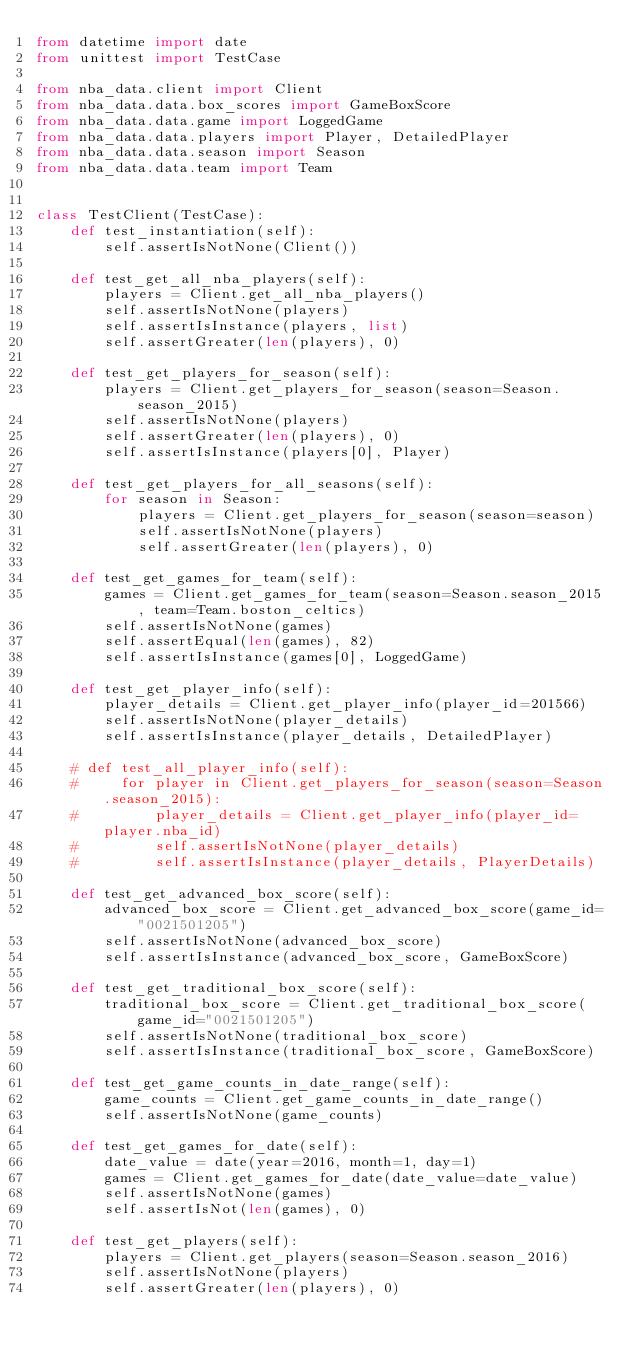<code> <loc_0><loc_0><loc_500><loc_500><_Python_>from datetime import date
from unittest import TestCase

from nba_data.client import Client
from nba_data.data.box_scores import GameBoxScore
from nba_data.data.game import LoggedGame
from nba_data.data.players import Player, DetailedPlayer
from nba_data.data.season import Season
from nba_data.data.team import Team


class TestClient(TestCase):
    def test_instantiation(self):
        self.assertIsNotNone(Client())

    def test_get_all_nba_players(self):
        players = Client.get_all_nba_players()
        self.assertIsNotNone(players)
        self.assertIsInstance(players, list)
        self.assertGreater(len(players), 0)

    def test_get_players_for_season(self):
        players = Client.get_players_for_season(season=Season.season_2015)
        self.assertIsNotNone(players)
        self.assertGreater(len(players), 0)
        self.assertIsInstance(players[0], Player)

    def test_get_players_for_all_seasons(self):
        for season in Season:
            players = Client.get_players_for_season(season=season)
            self.assertIsNotNone(players)
            self.assertGreater(len(players), 0)

    def test_get_games_for_team(self):
        games = Client.get_games_for_team(season=Season.season_2015, team=Team.boston_celtics)
        self.assertIsNotNone(games)
        self.assertEqual(len(games), 82)
        self.assertIsInstance(games[0], LoggedGame)

    def test_get_player_info(self):
        player_details = Client.get_player_info(player_id=201566)
        self.assertIsNotNone(player_details)
        self.assertIsInstance(player_details, DetailedPlayer)

    # def test_all_player_info(self):
    #     for player in Client.get_players_for_season(season=Season.season_2015):
    #         player_details = Client.get_player_info(player_id=player.nba_id)
    #         self.assertIsNotNone(player_details)
    #         self.assertIsInstance(player_details, PlayerDetails)

    def test_get_advanced_box_score(self):
        advanced_box_score = Client.get_advanced_box_score(game_id="0021501205")
        self.assertIsNotNone(advanced_box_score)
        self.assertIsInstance(advanced_box_score, GameBoxScore)

    def test_get_traditional_box_score(self):
        traditional_box_score = Client.get_traditional_box_score(game_id="0021501205")
        self.assertIsNotNone(traditional_box_score)
        self.assertIsInstance(traditional_box_score, GameBoxScore)

    def test_get_game_counts_in_date_range(self):
        game_counts = Client.get_game_counts_in_date_range()
        self.assertIsNotNone(game_counts)

    def test_get_games_for_date(self):
        date_value = date(year=2016, month=1, day=1)
        games = Client.get_games_for_date(date_value=date_value)
        self.assertIsNotNone(games)
        self.assertIsNot(len(games), 0)

    def test_get_players(self):
        players = Client.get_players(season=Season.season_2016)
        self.assertIsNotNone(players)
        self.assertGreater(len(players), 0)

</code> 